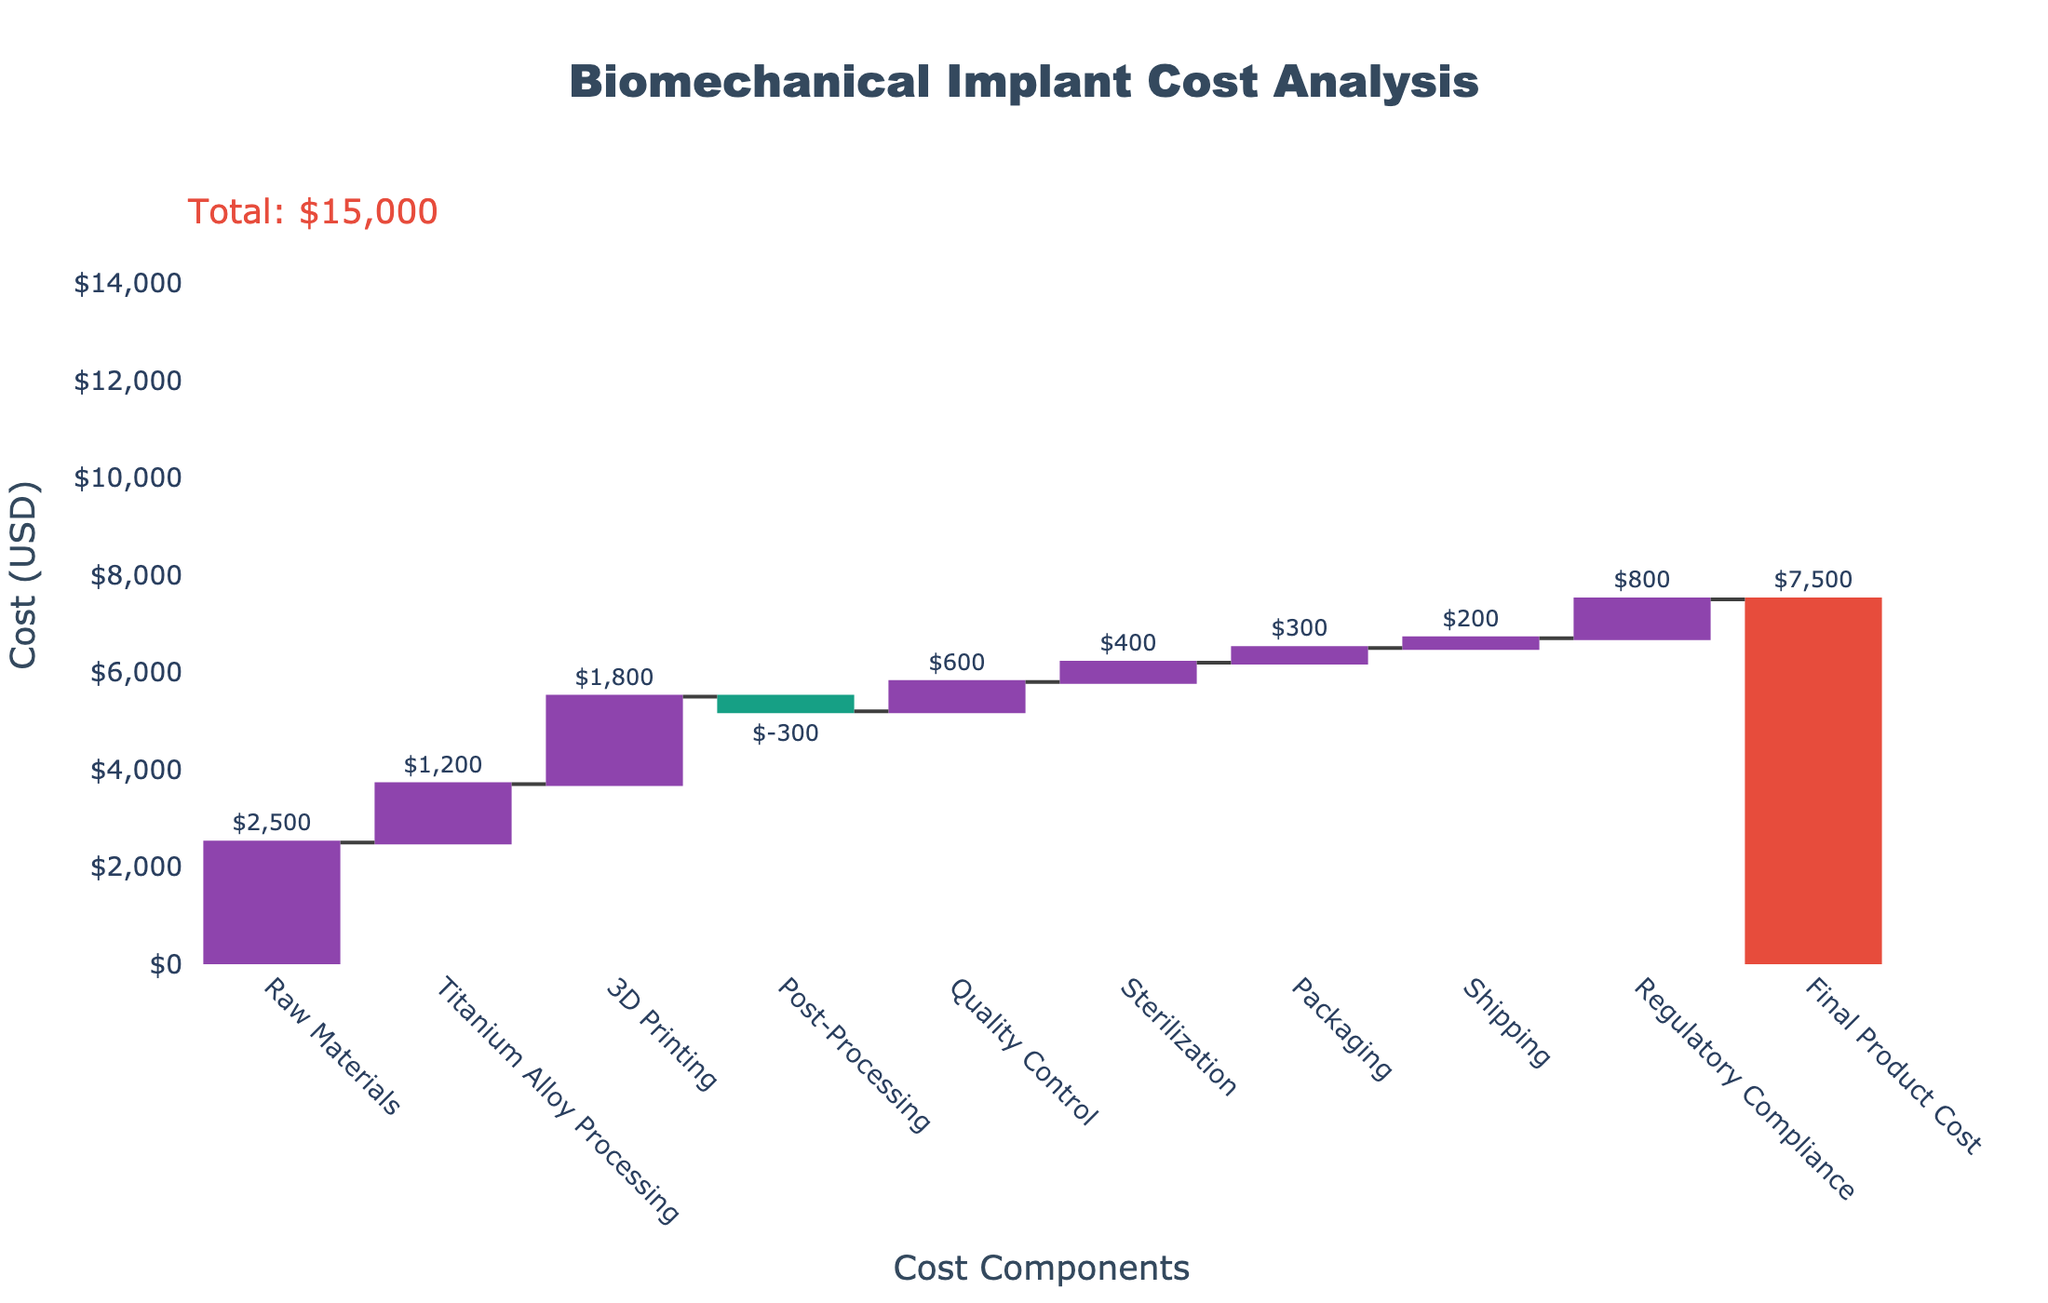What is the title of the chart? The title is shown at the top center of the chart.
Answer: Biomechanical Implant Cost Analysis Which component has the highest cost? By examining the chart, the tallest bar represents Raw Materials with a value of $2,500.
Answer: Raw Materials What is the total cost of the final product? The total cost is annotated near the last bar, representing the final step in the waterfall chart.
Answer: $7,500 How much does Quality Control cost? The height and label of the bar for Quality Control indicate its cost.
Answer: $600 What are the steps involved in the process after 3D Printing? Look at the categories that come after 3D Printing in the x-axis sequence: Post-Processing, Quality Control, Sterilization, Packaging, Shipping, Regulatory Compliance, and then the Final Product Cost.
Answer: Post-Processing, Quality Control, Sterilization, Packaging, Shipping, Regulatory Compliance, Final Product Cost Calculate the total cost added by Titanium Alloy Processing and Sterilization. Sum the values for Titanium Alloy Processing ($1,200) and Sterilization ($400).
Answer: $1,600 Which component decreases the cost and by how much? The green bar labeled Post-Processing represents a decrease in cost with a value of -$300.
Answer: Post-Processing, $300 How much more does Shipping cost compared to Packaging? Subtract the cost of Packaging ($300) from the cost of Shipping ($200).
Answer: Shipping costs $100 less than Packaging What is the total cost of the first three steps (Raw Materials, Titanium Alloy Processing, and 3D Printing)? Sum the values of Raw Materials ($2,500), Titanium Alloy Processing ($1,200), and 3D Printing ($1,800).
Answer: $5,500 Compare the costs of Regulatory Compliance and Titanium Alloy Processing. Which is higher and by how much? Regulatory Compliance costs $800 and Titanium Alloy Processing costs $1,200. Subtract these values to find the difference.
Answer: Titanium Alloy Processing is higher by $400 